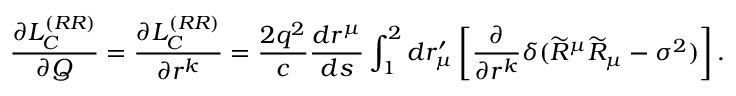Convert formula to latex. <formula><loc_0><loc_0><loc_500><loc_500>\frac { \partial L _ { C } ^ { ( R R ) } } { \partial Q } = \frac { \partial L _ { C } ^ { ( R R ) } } { \partial r ^ { k } } = \frac { 2 q ^ { 2 } } { c } \frac { d r ^ { \mu } } { d s } \int _ { 1 } ^ { 2 } d r _ { \mu } ^ { \prime } \left [ \frac { \partial } { \partial r ^ { k } } \delta ( \widetilde { R } ^ { \mu } \widetilde { R } _ { \mu } - \sigma ^ { 2 } ) \right ] .</formula> 